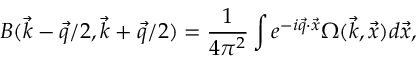<formula> <loc_0><loc_0><loc_500><loc_500>B ( \vec { k } - \vec { q } / 2 , \vec { k } + \vec { q } / 2 ) = \frac { 1 } { 4 \pi ^ { 2 } } \int e ^ { - i \vec { q } \cdot \vec { x } } \Omega ( \vec { k } , \vec { x } ) d \vec { x } ,</formula> 